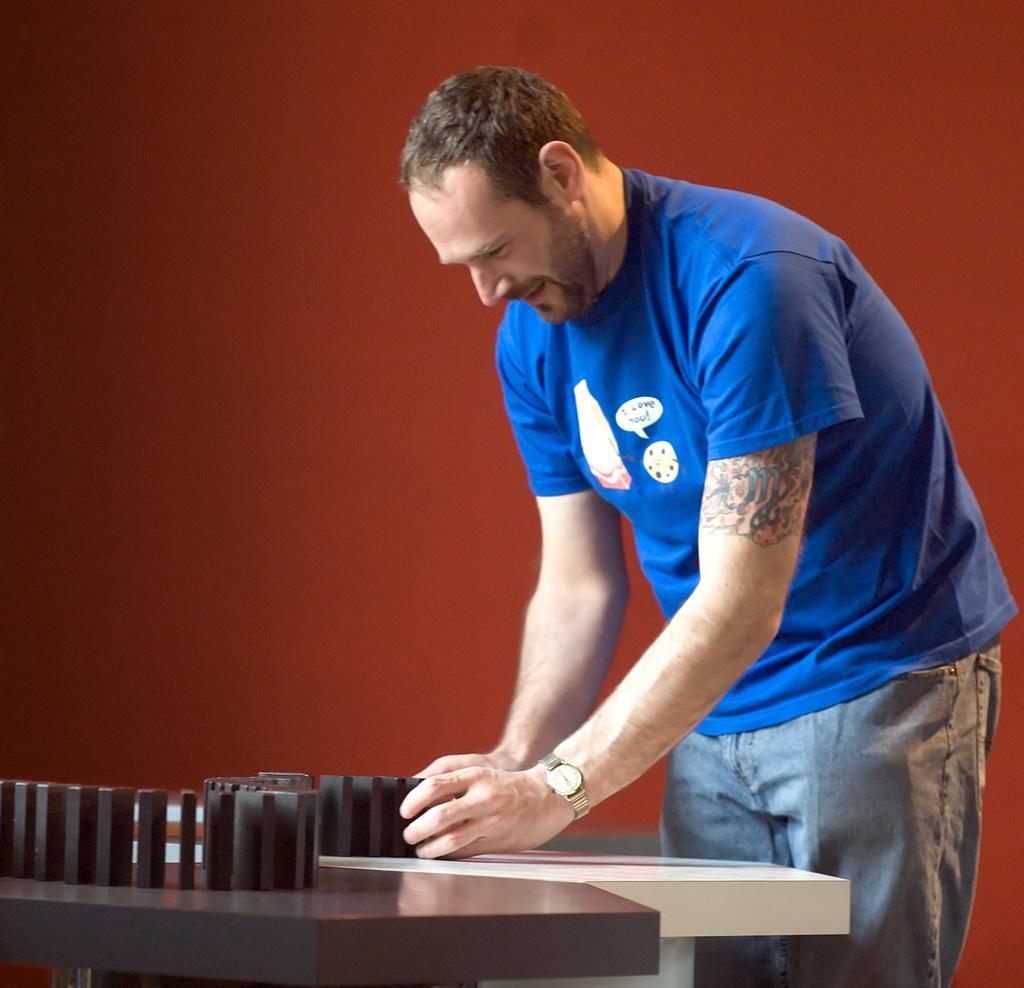Can you describe this image briefly? In this image there is one person standing, and he is doing something in front of him there is a table and objects and there is a color background. 